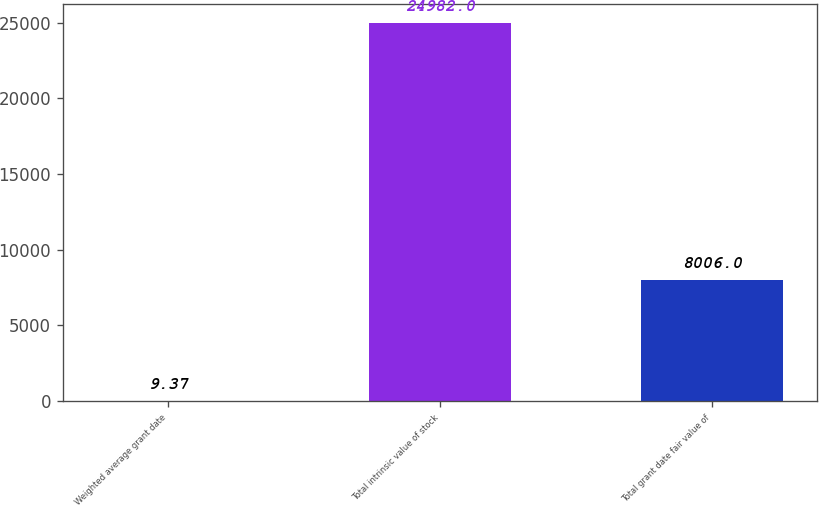Convert chart. <chart><loc_0><loc_0><loc_500><loc_500><bar_chart><fcel>Weighted average grant date<fcel>Total intrinsic value of stock<fcel>Total grant date fair value of<nl><fcel>9.37<fcel>24982<fcel>8006<nl></chart> 